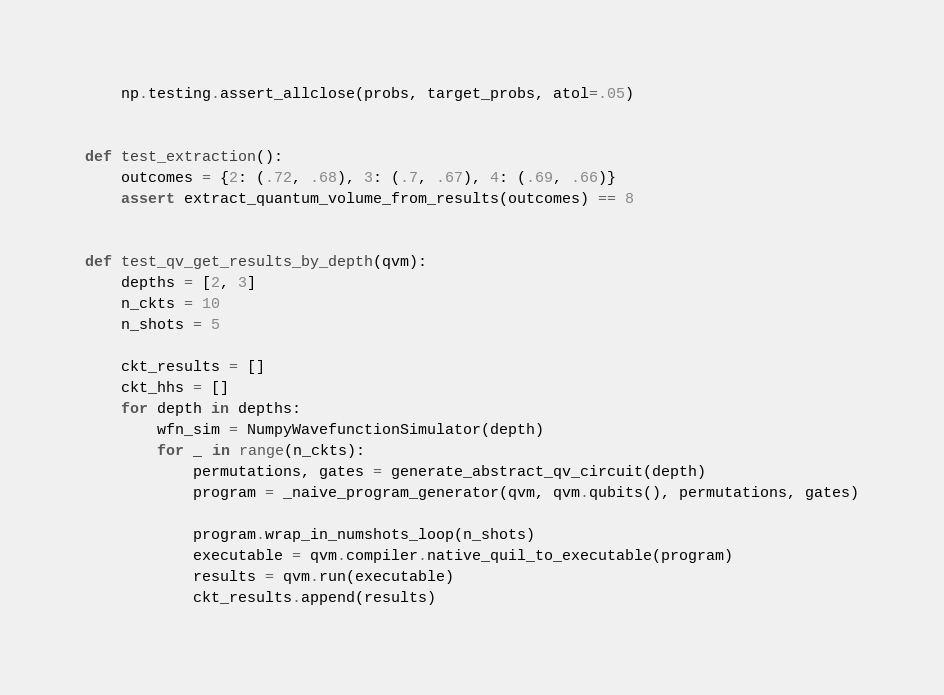Convert code to text. <code><loc_0><loc_0><loc_500><loc_500><_Python_>    np.testing.assert_allclose(probs, target_probs, atol=.05)


def test_extraction():
    outcomes = {2: (.72, .68), 3: (.7, .67), 4: (.69, .66)}
    assert extract_quantum_volume_from_results(outcomes) == 8


def test_qv_get_results_by_depth(qvm):
    depths = [2, 3]
    n_ckts = 10
    n_shots = 5

    ckt_results = []
    ckt_hhs = []
    for depth in depths:
        wfn_sim = NumpyWavefunctionSimulator(depth)
        for _ in range(n_ckts):
            permutations, gates = generate_abstract_qv_circuit(depth)
            program = _naive_program_generator(qvm, qvm.qubits(), permutations, gates)

            program.wrap_in_numshots_loop(n_shots)
            executable = qvm.compiler.native_quil_to_executable(program)
            results = qvm.run(executable)
            ckt_results.append(results)
</code> 